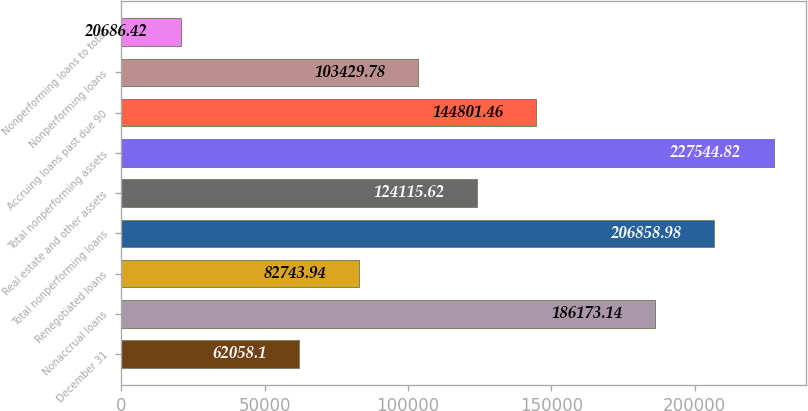Convert chart to OTSL. <chart><loc_0><loc_0><loc_500><loc_500><bar_chart><fcel>December 31<fcel>Nonaccrual loans<fcel>Renegotiated loans<fcel>Total nonperforming loans<fcel>Real estate and other assets<fcel>Total nonperforming assets<fcel>Accruing loans past due 90<fcel>Nonperforming loans<fcel>Nonperforming loans to total<nl><fcel>62058.1<fcel>186173<fcel>82743.9<fcel>206859<fcel>124116<fcel>227545<fcel>144801<fcel>103430<fcel>20686.4<nl></chart> 